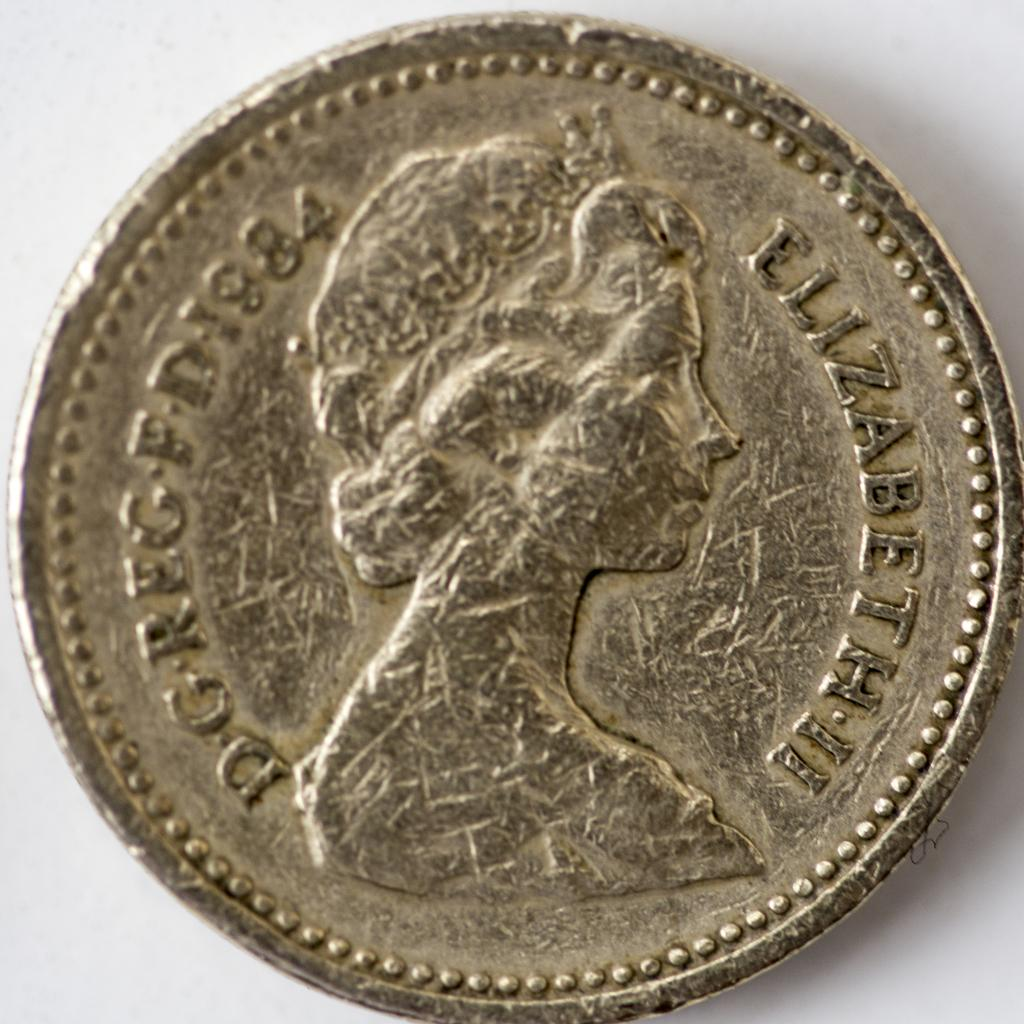<image>
Write a terse but informative summary of the picture. A scruffed up coin featuring Elizabeth II dated 1984. 